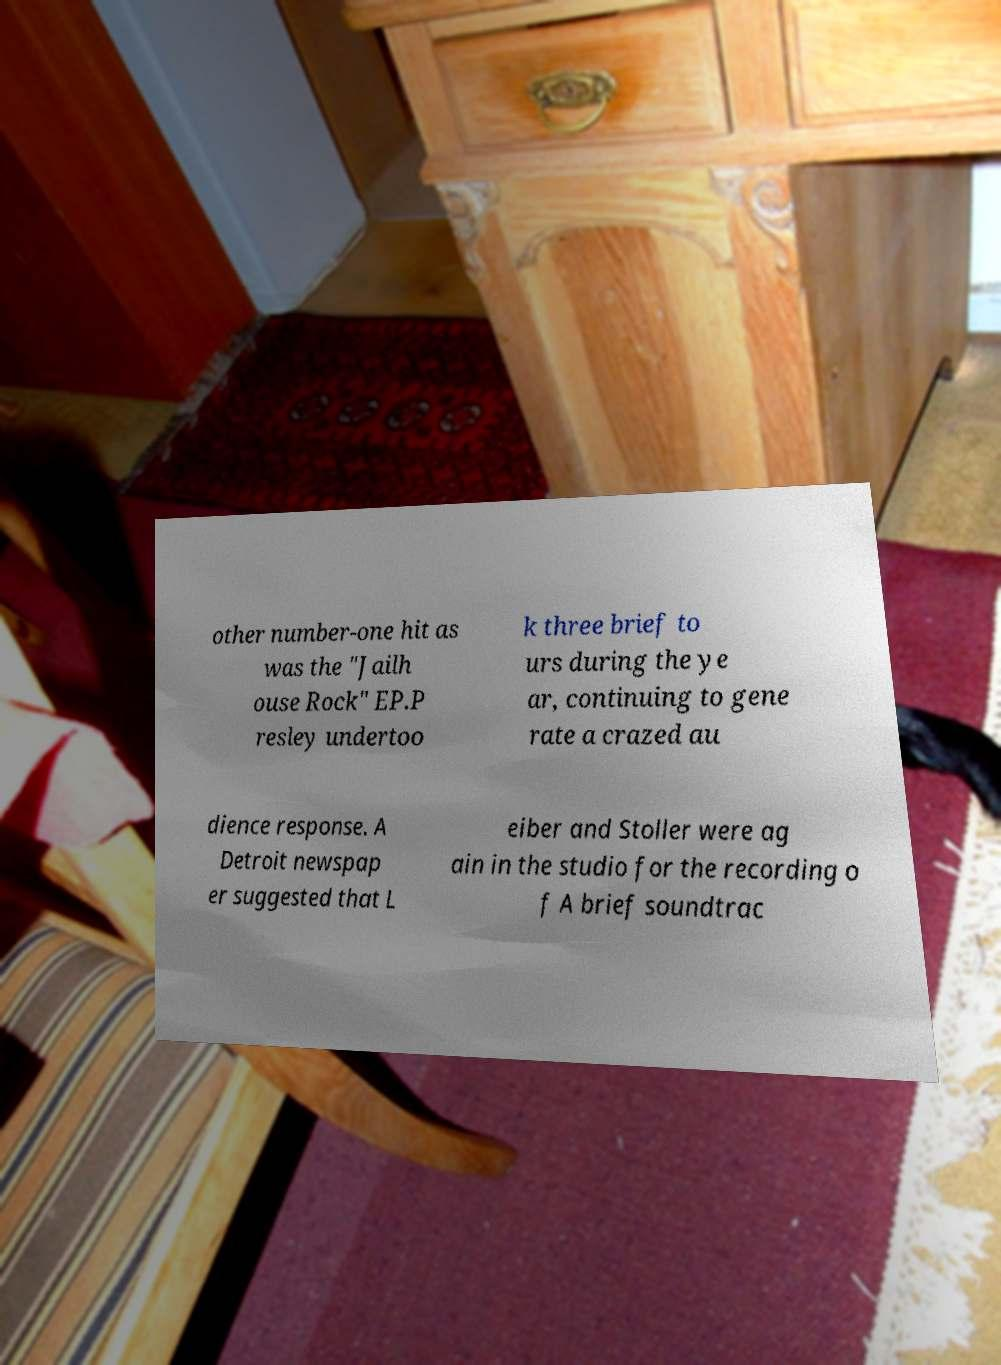Could you extract and type out the text from this image? other number-one hit as was the "Jailh ouse Rock" EP.P resley undertoo k three brief to urs during the ye ar, continuing to gene rate a crazed au dience response. A Detroit newspap er suggested that L eiber and Stoller were ag ain in the studio for the recording o f A brief soundtrac 